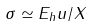Convert formula to latex. <formula><loc_0><loc_0><loc_500><loc_500>\sigma \simeq E _ { h } u / X</formula> 